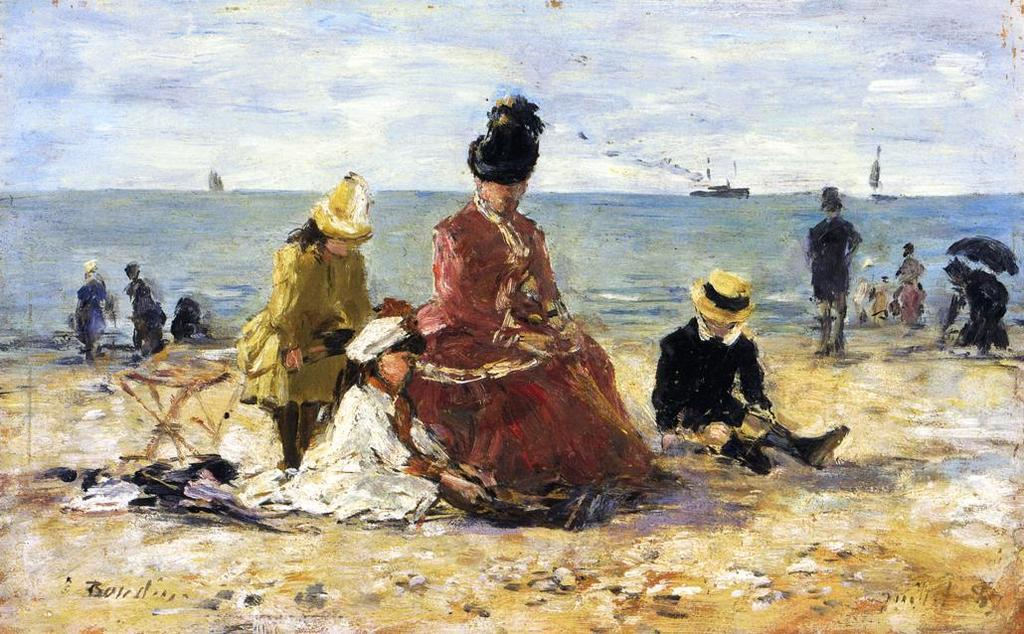What is the main subject of the image? The image contains a painting. What can be seen in the painting? There are persons depicted in the painting, along with the ground, water, boats, and sky. What is the water in the painting being used for? The water in the painting has boats on it, suggesting it is being used for transportation or leisure. How many elements can be seen in the background of the painting? The sky is visible in the background of the painting. What type of comb can be seen in the painting? There is no comb present in the painting; it features persons, ground, water, boats, and sky. Can you tell me where the playground is located in the painting? There is no playground depicted in the painting; it features persons, ground, water, boats, and sky. 